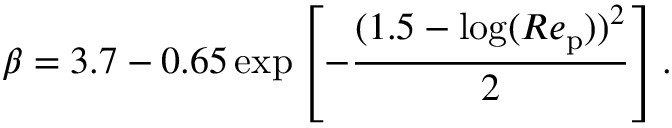<formula> <loc_0><loc_0><loc_500><loc_500>{ \beta } = 3 . 7 - 0 . 6 5 \exp \left [ - \frac { ( 1 . 5 - \log ( R e _ { p } ) ) ^ { 2 } } { 2 } \right ] .</formula> 